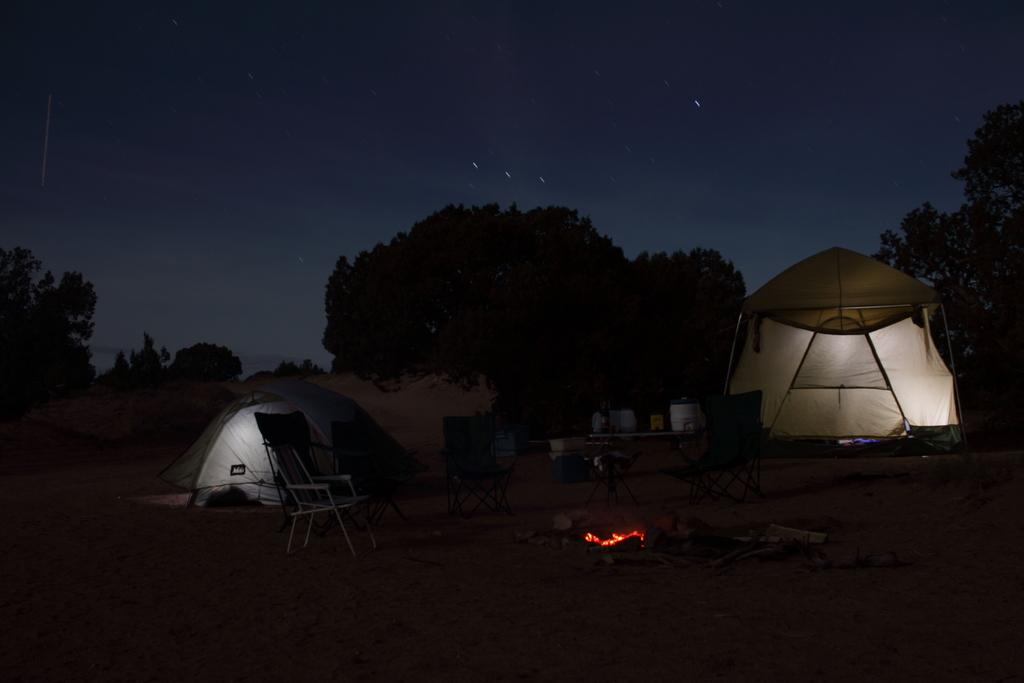What structures are visible on the ground in the image? There are tents on the ground in the image. What type of natural environment can be seen in the background of the image? There are trees in the background of the image. What is the condition of the sky in the image? The sky is clear in the image. Are there any gloves visible in the image? There are no gloves present in the image. Is it winter in the image? The provided facts do not mention the season, so we cannot determine if it is winter in the image. 